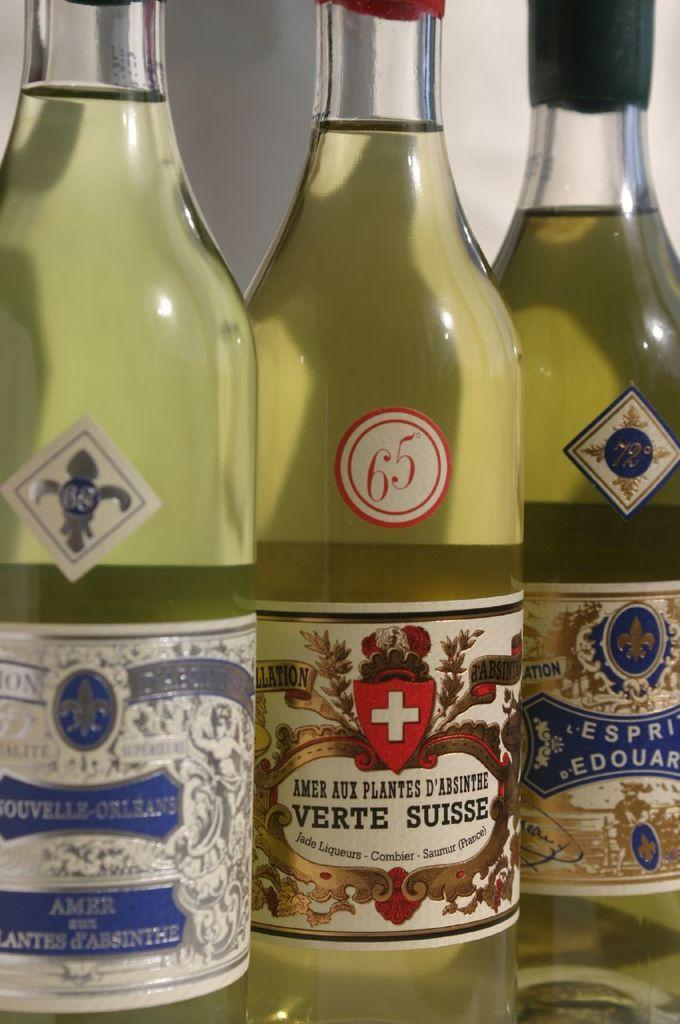How many bottles are visible in the image? There are three bottles in the image. What is inside the bottles? The bottles contain liquid. How many circles can be seen on the labels of the bottles? There is no information about the labels or the presence of circles on the bottles in the provided facts. 